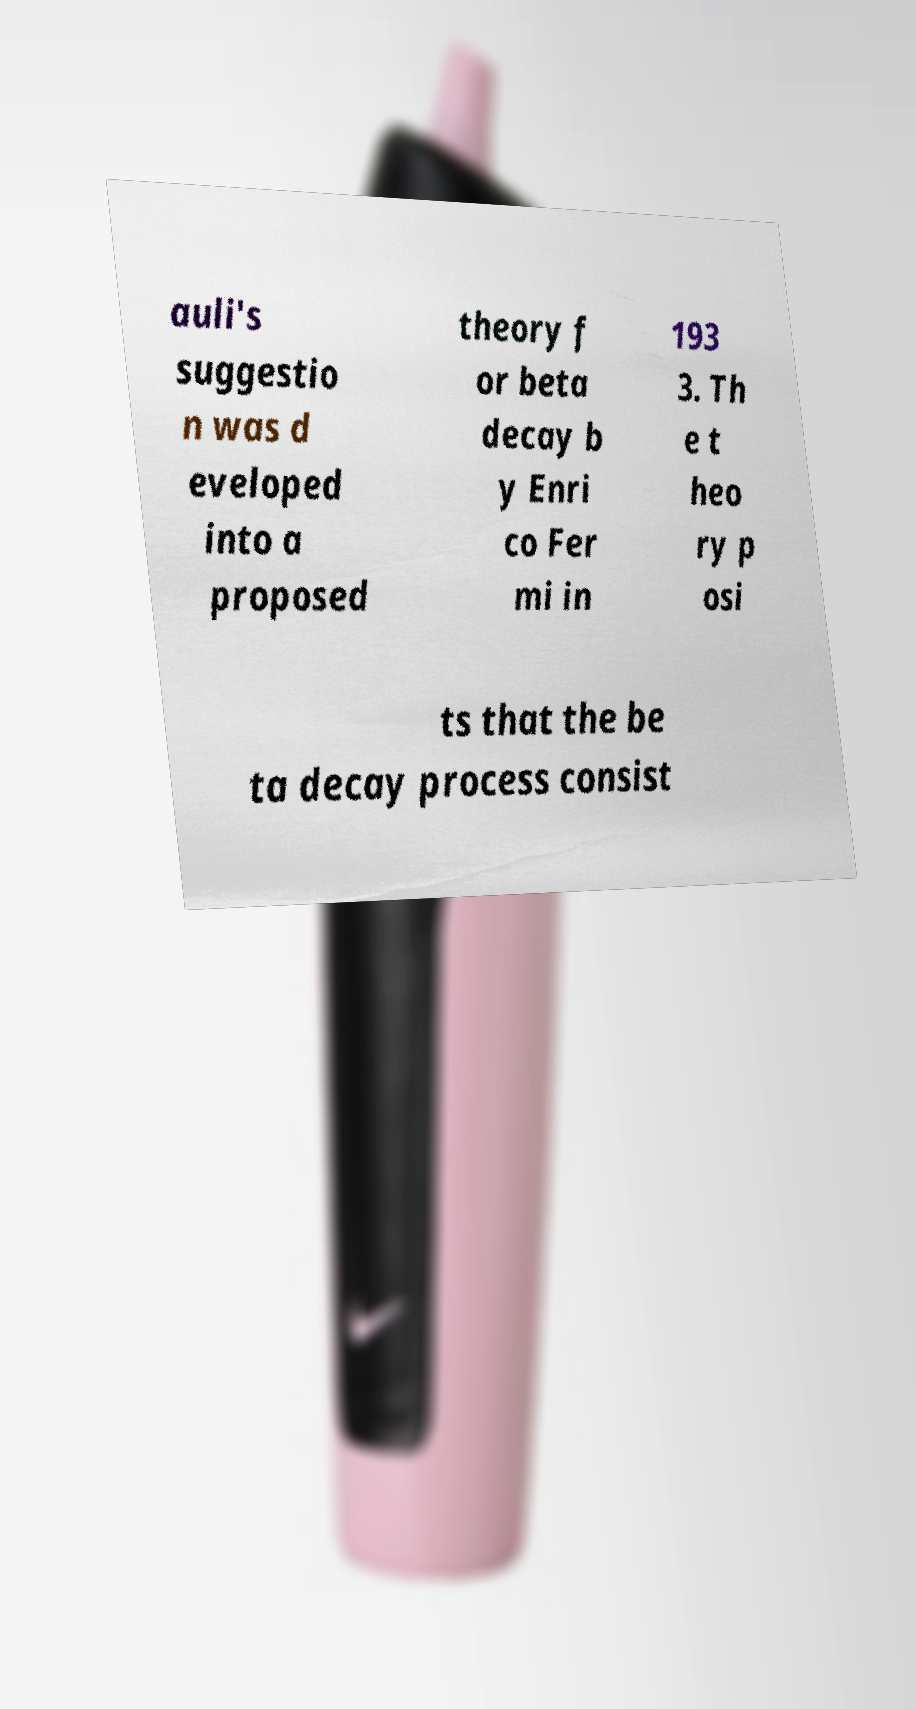What messages or text are displayed in this image? I need them in a readable, typed format. auli's suggestio n was d eveloped into a proposed theory f or beta decay b y Enri co Fer mi in 193 3. Th e t heo ry p osi ts that the be ta decay process consist 